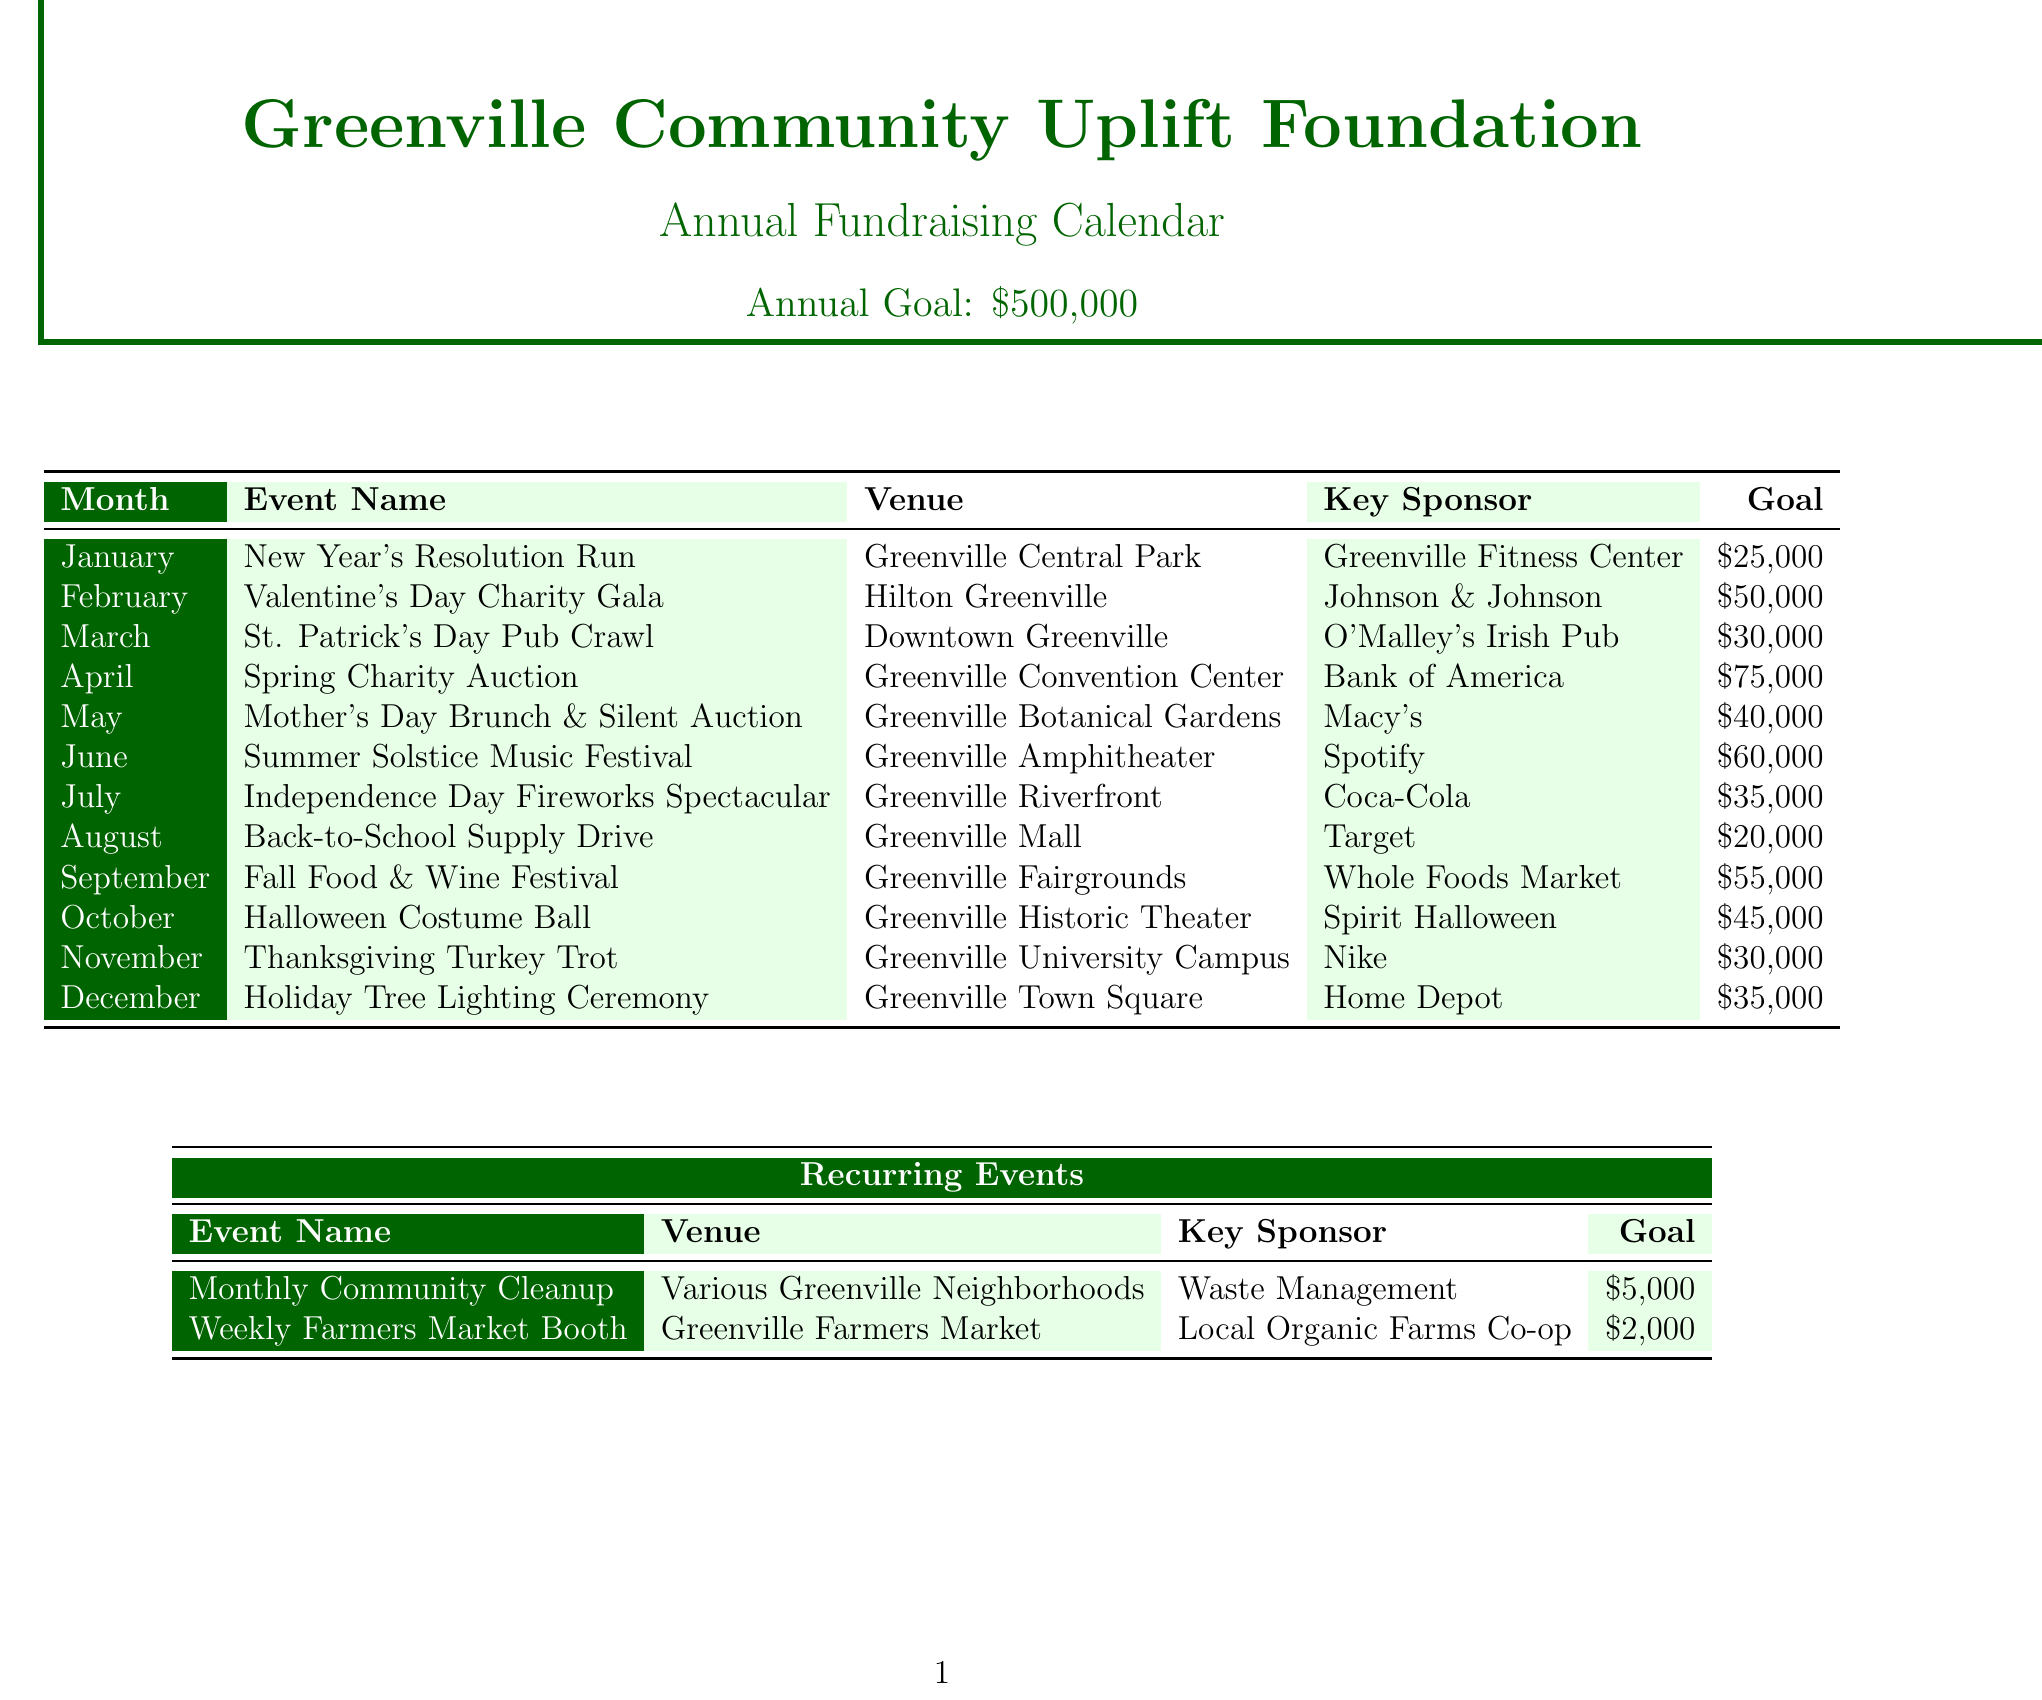what is the annual fundraising goal? The annual fundraising goal is stated clearly at the beginning of the document.
Answer: 500000 what event is scheduled for April? The event scheduled for April is listed in the monthly events section.
Answer: Spring Charity Auction who is the key sponsor for the February event? The key sponsor for the February event can be found in the details of the Valentine's Day Charity Gala.
Answer: Johnson & Johnson how much is the goal for the Halloween event? The goal for the Halloween event is provided in the event details for October.
Answer: 45000 which venue will host the Summer Solstice Music Festival? The venue for the Summer Solstice Music Festival is mentioned in the event information for June.
Answer: Greenville Amphitheater what is the total goal for recurring events each month? The total goal for recurring events is the sum of the individual goals listed in the recurring events section.
Answer: 7000 how many events are there in the document for July? The document lists the events for each month, and we can identify how many are scheduled for July.
Answer: 1 which grant has the highest potential funding? The potential funding for each grant is listed, and we need to identify the one with the highest amount.
Answer: Greenville Community Foundation Grant when is the deadline for the National Nonprofit Support Initiative grant? The deadline for the National Nonprofit Support Initiative is specified in the grant applications table.
Answer: September 15 